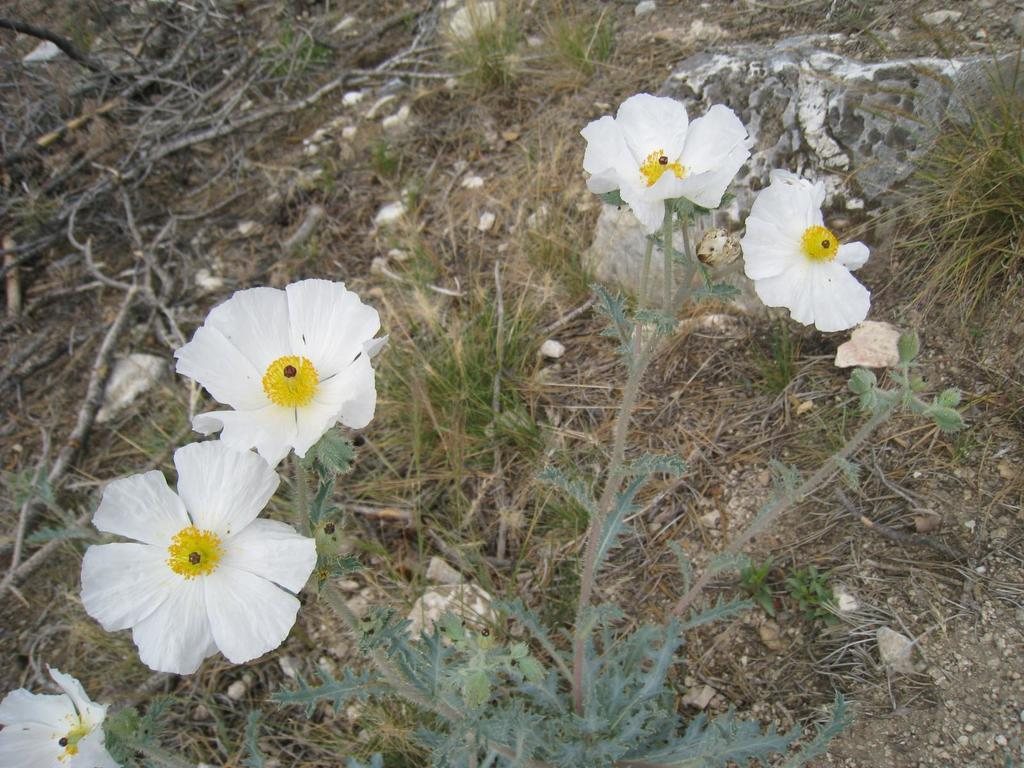What type of vegetation can be seen in the image? There are flowers, plants, and grass visible in the image. What other natural elements can be seen in the image? There is a rock, stones, and sticks visible in the image. What is the ground like in the image? The ground is visible in the image. What position does the brick hold in the image? There is no brick present in the image. Who is the partner of the flowers in the image? The flowers do not have a partner in the image; they are individual plants. 